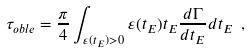Convert formula to latex. <formula><loc_0><loc_0><loc_500><loc_500>\tau _ { o b l e } = \frac { \pi } { 4 } \int _ { \varepsilon ( t _ { E } ) > 0 } { \varepsilon ( t _ { E } ) t _ { E } \frac { d \Gamma } { d t _ { E } } d t _ { E } } \ ,</formula> 